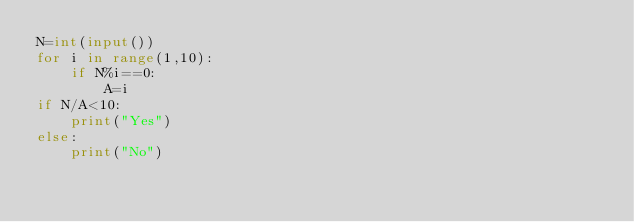Convert code to text. <code><loc_0><loc_0><loc_500><loc_500><_Python_>N=int(input())
for i in range(1,10):
    if N%i==0:
        A=i
if N/A<10:
    print("Yes")
else:
    print("No")
    </code> 